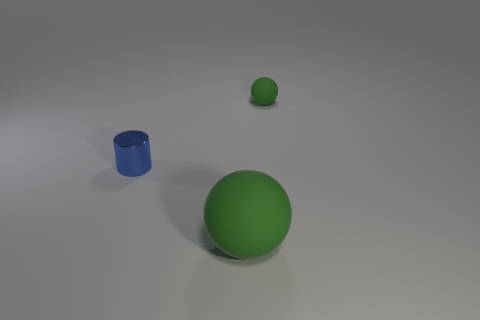There is a rubber thing that is the same color as the large ball; what is its shape?
Offer a very short reply. Sphere. What color is the thing that is behind the blue metal object?
Your answer should be compact. Green. There is a green ball that is made of the same material as the big green object; what is its size?
Offer a terse response. Small. Do the blue metallic cylinder and the matte ball that is behind the cylinder have the same size?
Your answer should be compact. Yes. There is a green ball that is behind the big green thing; what material is it?
Keep it short and to the point. Rubber. There is a matte sphere behind the large green matte sphere; what number of small green matte balls are right of it?
Your answer should be very brief. 0. Are there any shiny objects that have the same shape as the small matte object?
Your answer should be very brief. No. Is the size of the green ball that is behind the blue metal cylinder the same as the object that is left of the large sphere?
Give a very brief answer. Yes. What shape is the green object that is behind the matte ball in front of the blue thing?
Offer a terse response. Sphere. How many yellow rubber cylinders have the same size as the blue metallic object?
Provide a succinct answer. 0. 